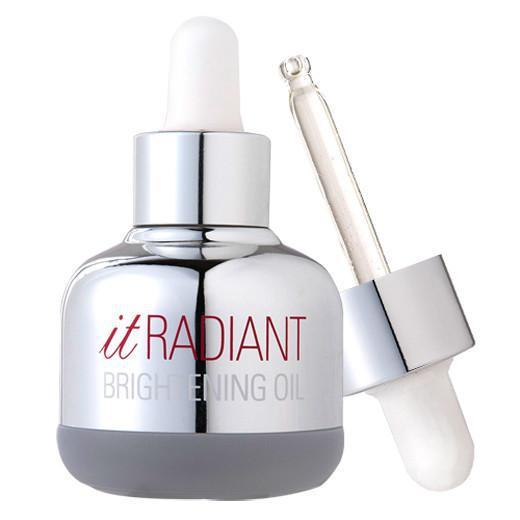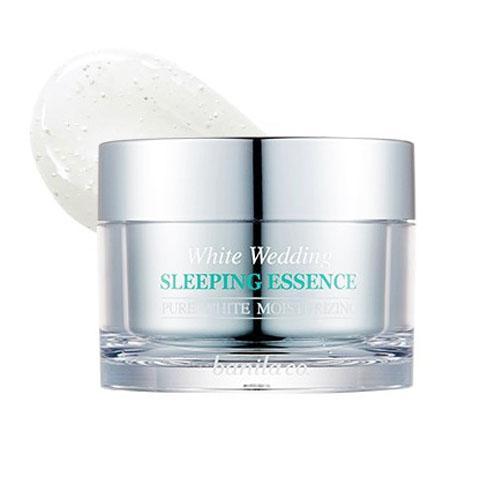The first image is the image on the left, the second image is the image on the right. Considering the images on both sides, is "One image shows a single bottle with its applicator top next to it." valid? Answer yes or no. Yes. The first image is the image on the left, the second image is the image on the right. Evaluate the accuracy of this statement regarding the images: "There are a total of two beauty product containers.". Is it true? Answer yes or no. Yes. 